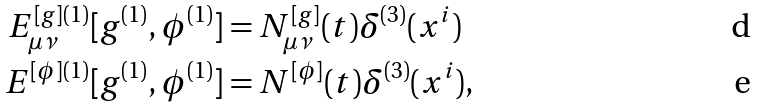<formula> <loc_0><loc_0><loc_500><loc_500>E ^ { [ g ] ( 1 ) } _ { \mu \nu } [ g ^ { ( 1 ) } , \phi ^ { ( 1 ) } ] & = N ^ { [ g ] } _ { \mu \nu } ( t ) \delta ^ { ( 3 ) } ( x ^ { i } ) \\ E ^ { [ \phi ] ( 1 ) } [ g ^ { ( 1 ) } , \phi ^ { ( 1 ) } ] & = N ^ { [ \phi ] } ( t ) \delta ^ { ( 3 ) } ( x ^ { i } ) ,</formula> 